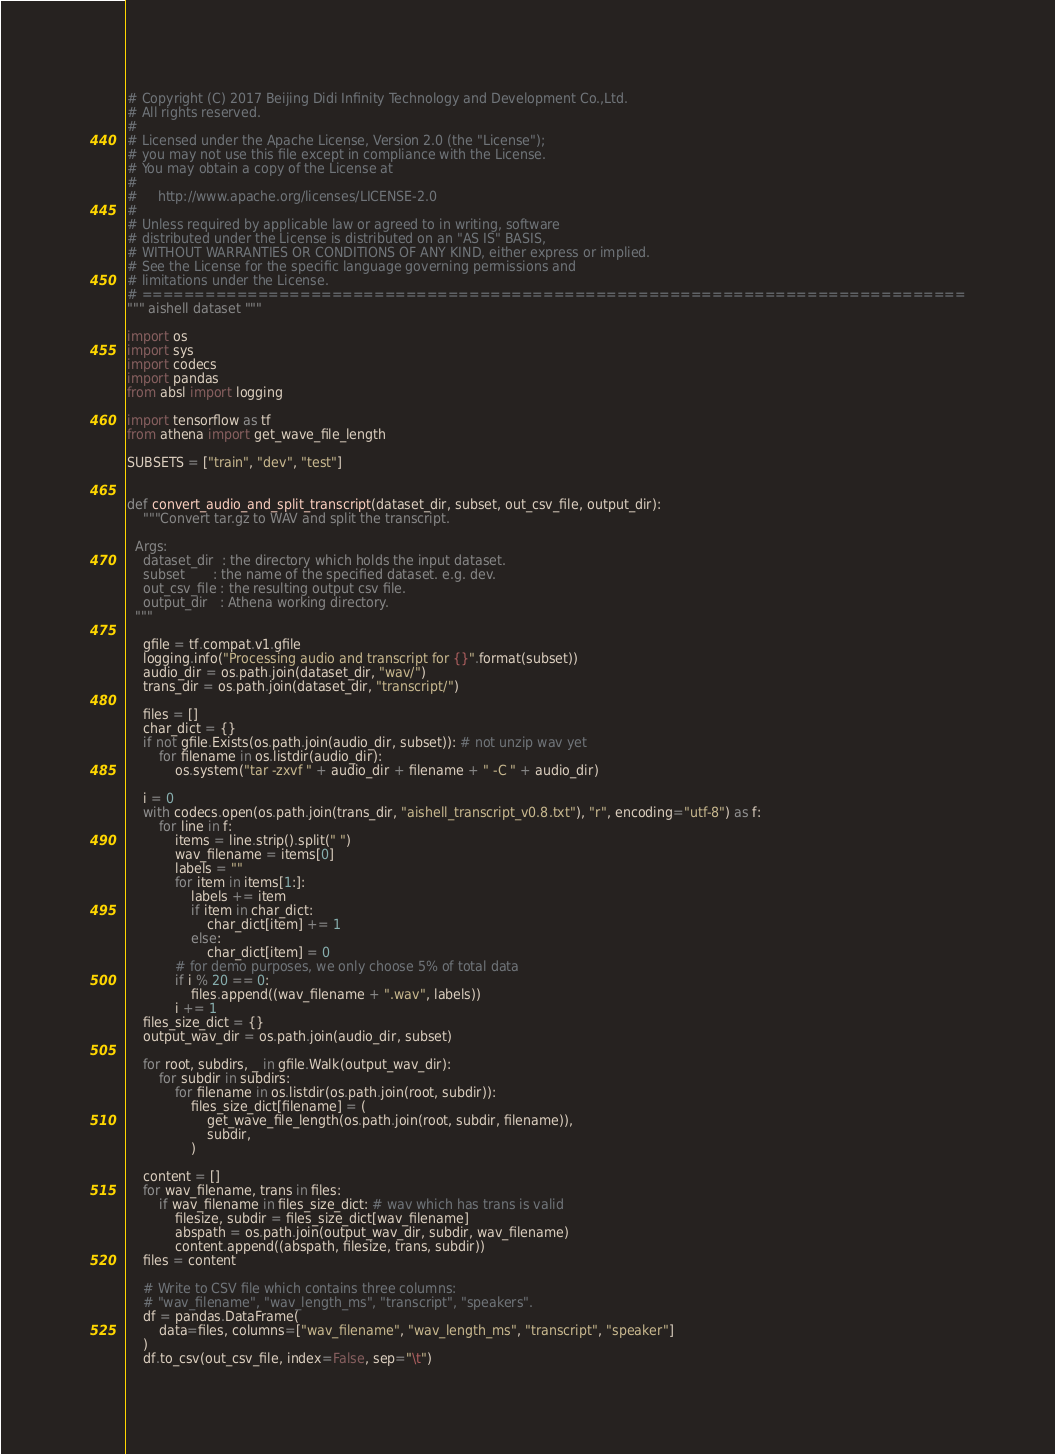<code> <loc_0><loc_0><loc_500><loc_500><_Python_># Copyright (C) 2017 Beijing Didi Infinity Technology and Development Co.,Ltd.
# All rights reserved.
#
# Licensed under the Apache License, Version 2.0 (the "License");
# you may not use this file except in compliance with the License.
# You may obtain a copy of the License at
#
#     http://www.apache.org/licenses/LICENSE-2.0
#
# Unless required by applicable law or agreed to in writing, software
# distributed under the License is distributed on an "AS IS" BASIS,
# WITHOUT WARRANTIES OR CONDITIONS OF ANY KIND, either express or implied.
# See the License for the specific language governing permissions and
# limitations under the License.
# ==============================================================================
""" aishell dataset """

import os
import sys
import codecs
import pandas
from absl import logging

import tensorflow as tf
from athena import get_wave_file_length

SUBSETS = ["train", "dev", "test"]


def convert_audio_and_split_transcript(dataset_dir, subset, out_csv_file, output_dir):
    """Convert tar.gz to WAV and split the transcript.

  Args:
    dataset_dir  : the directory which holds the input dataset.
    subset       : the name of the specified dataset. e.g. dev.
    out_csv_file : the resulting output csv file.
    output_dir   : Athena working directory.
  """

    gfile = tf.compat.v1.gfile
    logging.info("Processing audio and transcript for {}".format(subset))
    audio_dir = os.path.join(dataset_dir, "wav/")
    trans_dir = os.path.join(dataset_dir, "transcript/")

    files = []
    char_dict = {}
    if not gfile.Exists(os.path.join(audio_dir, subset)): # not unzip wav yet
        for filename in os.listdir(audio_dir):
            os.system("tar -zxvf " + audio_dir + filename + " -C " + audio_dir)

    i = 0
    with codecs.open(os.path.join(trans_dir, "aishell_transcript_v0.8.txt"), "r", encoding="utf-8") as f:
        for line in f:
            items = line.strip().split(" ")
            wav_filename = items[0]
            labels = ""
            for item in items[1:]:
                labels += item
                if item in char_dict:
                    char_dict[item] += 1
                else:
                    char_dict[item] = 0
            # for demo purposes, we only choose 5% of total data
            if i % 20 == 0:
                files.append((wav_filename + ".wav", labels))
            i += 1
    files_size_dict = {}
    output_wav_dir = os.path.join(audio_dir, subset)

    for root, subdirs, _ in gfile.Walk(output_wav_dir):
        for subdir in subdirs:
            for filename in os.listdir(os.path.join(root, subdir)):
                files_size_dict[filename] = (
                    get_wave_file_length(os.path.join(root, subdir, filename)),
                    subdir,
                )

    content = []
    for wav_filename, trans in files:
        if wav_filename in files_size_dict: # wav which has trans is valid
            filesize, subdir = files_size_dict[wav_filename]
            abspath = os.path.join(output_wav_dir, subdir, wav_filename)
            content.append((abspath, filesize, trans, subdir))
    files = content

    # Write to CSV file which contains three columns:
    # "wav_filename", "wav_length_ms", "transcript", "speakers".
    df = pandas.DataFrame(
        data=files, columns=["wav_filename", "wav_length_ms", "transcript", "speaker"]
    )
    df.to_csv(out_csv_file, index=False, sep="\t")</code> 